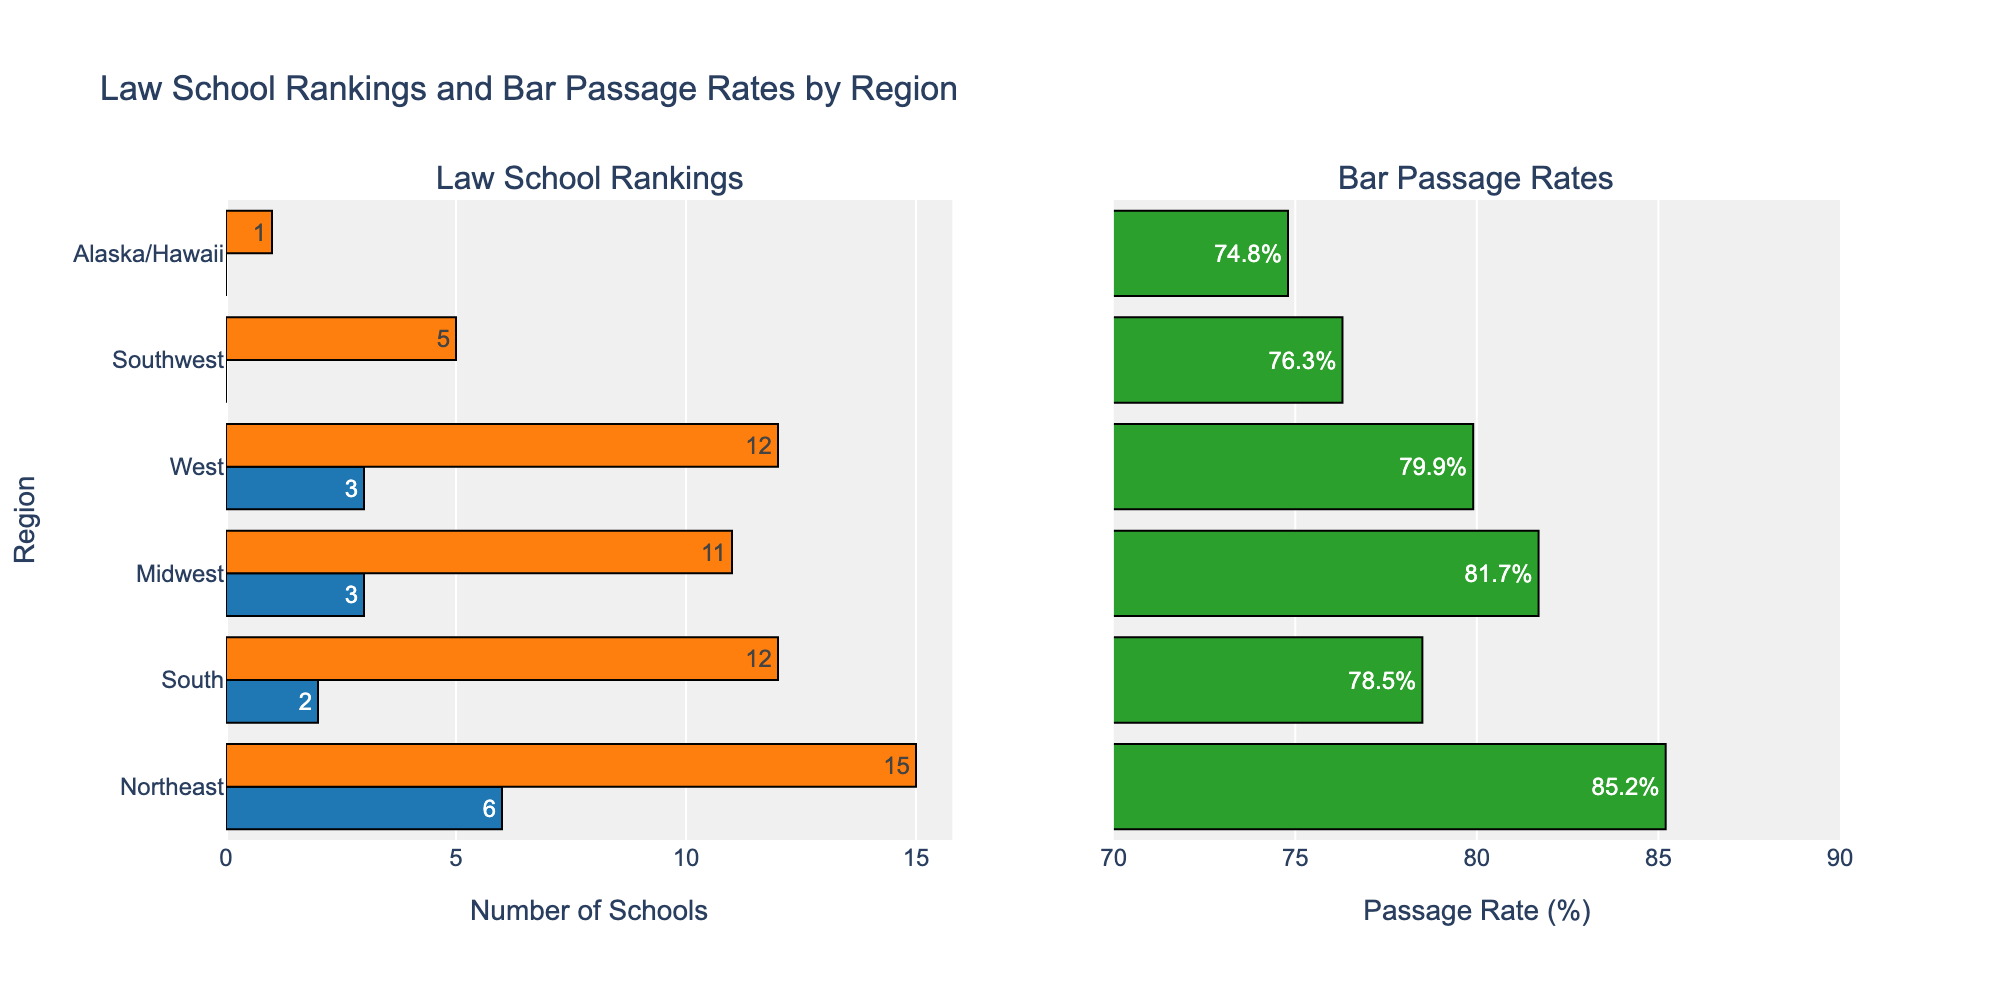What's the title of the figure? The title is usually displayed at the top of the figure. For this figure, it should clearly mention the two main aspects being compared.
Answer: Law School Rankings and Bar Passage Rates by Region Which region has the highest bar passage rate? By looking at the horizontal bars in the "Bar Passage Rate" subplot, you can identify the region with the longest bar and highest value.
Answer: Northeast How many Top 14 Schools are in the Midwest? Refer to the bar representing the Midwest in the "Law School Rankings" subplot and check the value corresponding to the "Top 14 Schools".
Answer: 3 Which region has the fewest Top 50 Schools? By comparing the lengths of the bars for "Top 50 Schools" across all regions, identify the shortest one.
Answer: Alaska/Hawaii What is the difference in bar passage rates between the Northeast and the Southwest? Subtract the bar passage rate of the Southwest from that of the Northeast. The values can be read off directly from the subplot.
Answer: 85.2 - 76.3 = 8.9 How do the Top 50 Schools in the South compare to those in the West? Compare the length of the bars for "Top 50 Schools" for both regions in the "Law School Rankings" subplot.
Answer: The South has fewer Top 50 Schools than the West (12 vs. 12; equal) What is the combined number of Top 14 and Top 50 Schools in the South? Add the values for "Top 14 Schools" and "Top 50 Schools" in the South from the "Law School Rankings" subplot.
Answer: 2 + 12 = 14 In which region do students have a higher bar passage rate: the South or the Midwest? Compare the bar lengths for the bar passage rates of both regions in the "Bar Passage Rate" subplot.
Answer: Midwest How does the number of Top 14 Schools in the West compare to that in the Northeast? Compare the lengths of the bars for "Top 14 Schools" in both the West and the Northeast regions.
Answer: The Northeast has more (6 vs. 3) Which region has the lowest bar passage rate? Look at the bars in the "Bar Passage Rate" subplot and identify the shortest one.
Answer: Alaska/Hawaii 